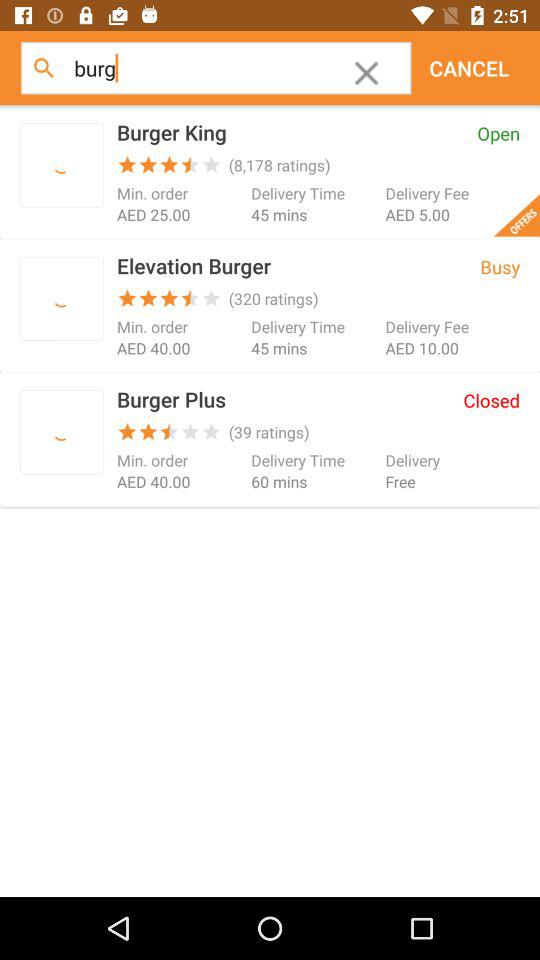Which store is open? The store that is open is "Burger King". 